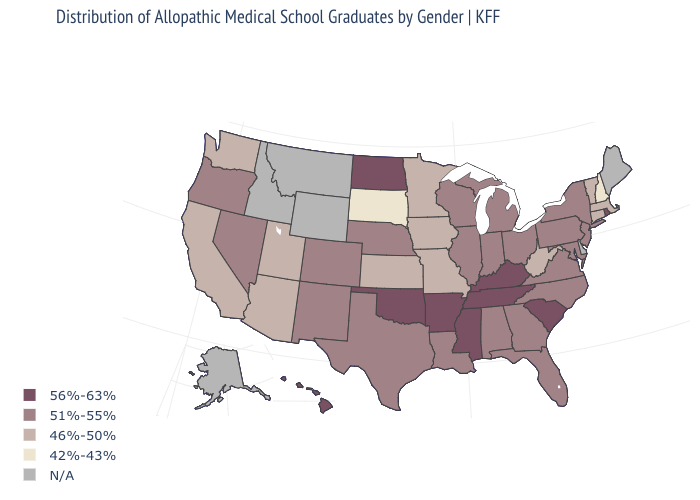Name the states that have a value in the range N/A?
Quick response, please. Alaska, Delaware, Idaho, Maine, Montana, Wyoming. Which states have the lowest value in the USA?
Quick response, please. New Hampshire, South Dakota. Name the states that have a value in the range 46%-50%?
Write a very short answer. Arizona, California, Connecticut, Iowa, Kansas, Massachusetts, Minnesota, Missouri, Utah, Vermont, Washington, West Virginia. What is the highest value in the West ?
Short answer required. 56%-63%. Which states hav the highest value in the Northeast?
Write a very short answer. Rhode Island. What is the value of Tennessee?
Answer briefly. 56%-63%. What is the highest value in the USA?
Quick response, please. 56%-63%. Name the states that have a value in the range 56%-63%?
Short answer required. Arkansas, Hawaii, Kentucky, Mississippi, North Dakota, Oklahoma, Rhode Island, South Carolina, Tennessee. What is the lowest value in the USA?
Quick response, please. 42%-43%. Among the states that border Alabama , which have the highest value?
Keep it brief. Mississippi, Tennessee. Does North Carolina have the highest value in the USA?
Quick response, please. No. Name the states that have a value in the range 46%-50%?
Concise answer only. Arizona, California, Connecticut, Iowa, Kansas, Massachusetts, Minnesota, Missouri, Utah, Vermont, Washington, West Virginia. Name the states that have a value in the range N/A?
Keep it brief. Alaska, Delaware, Idaho, Maine, Montana, Wyoming. What is the value of New Hampshire?
Write a very short answer. 42%-43%. Name the states that have a value in the range 42%-43%?
Be succinct. New Hampshire, South Dakota. 